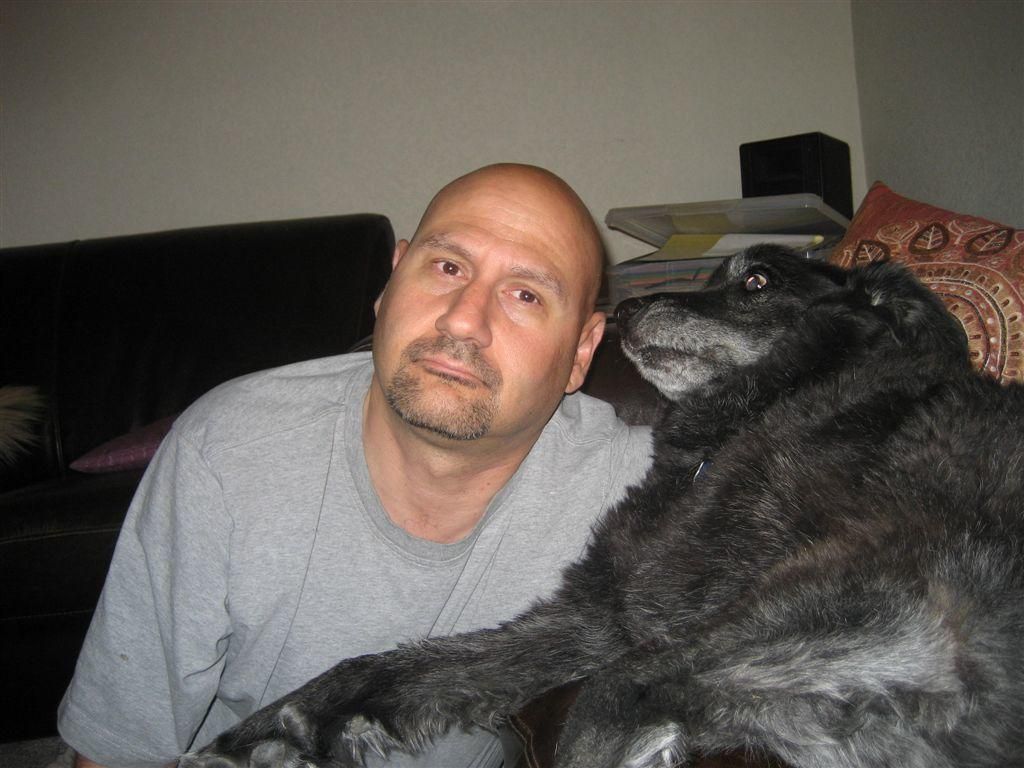Who is present in the image? There is a man in the image. What type of animal is in the image? There is a black dog in the image. What type of furniture can be seen in the background of the image? There is a sofa in the background of the image. What other items are present in the background of the image? There are pillows in the background of the image. How does the man solve the addition problem on the comb in the image? There is no addition problem or comb present in the image. 